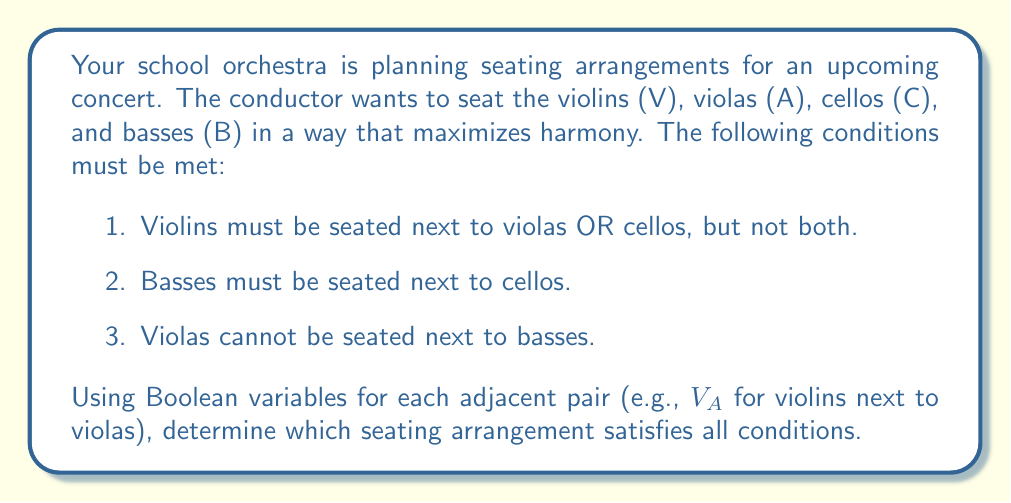Help me with this question. Let's approach this step-by-step using Boolean algebra:

1) Define Boolean variables:
   $V_A$: Violins next to violas
   $V_C$: Violins next to cellos
   $C_B$: Cellos next to basses
   $A_B$: Violas next to basses

2) Translate the conditions into Boolean expressions:
   Condition 1: $(V_A \oplus V_C)$ (exclusive OR)
   Condition 2: $C_B$
   Condition 3: $\neg A_B$

3) The overall expression that must be true:
   $$(V_A \oplus V_C) \land C_B \land \neg A_B$$

4) Now, let's consider possible arrangements:
   VACB: $V_A = 1, V_C = 0, C_B = 1, A_B = 0$
   VCAB: $V_A = 0, V_C = 1, C_B = 0, A_B = 1$
   VBCA: $V_A = 0, V_C = 0, C_B = 1, A_B = 0$
   VCBA: $V_A = 0, V_C = 1, C_B = 1, A_B = 0$

5) Evaluate each arrangement:
   VACB: $(1 \oplus 0) \land 1 \land \neg 0 = 1 \land 1 \land 1 = 1$
   VCAB: $(0 \oplus 1) \land 0 \land \neg 1 = 1 \land 0 \land 0 = 0$
   VBCA: $(0 \oplus 0) \land 1 \land \neg 0 = 0 \land 1 \land 1 = 0$
   VCBA: $(0 \oplus 1) \land 1 \land \neg 0 = 1 \land 1 \land 1 = 1$

6) The arrangements that satisfy all conditions are VACB and VCBA.
Answer: VACB or VCBA 